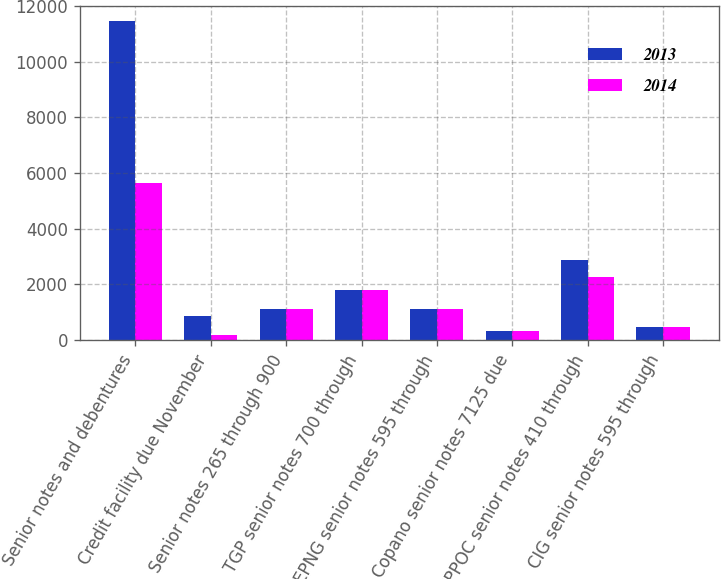Convert chart. <chart><loc_0><loc_0><loc_500><loc_500><stacked_bar_chart><ecel><fcel>Senior notes and debentures<fcel>Credit facility due November<fcel>Senior notes 265 through 900<fcel>TGP senior notes 700 through<fcel>EPNG senior notes 595 through<fcel>Copano senior notes 7125 due<fcel>EPPOC senior notes 410 through<fcel>CIG senior notes 595 through<nl><fcel>2013<fcel>11438<fcel>850<fcel>1115<fcel>1790<fcel>1115<fcel>332<fcel>2860<fcel>475<nl><fcel>2014<fcel>5645<fcel>175<fcel>1115<fcel>1790<fcel>1115<fcel>332<fcel>2260<fcel>475<nl></chart> 